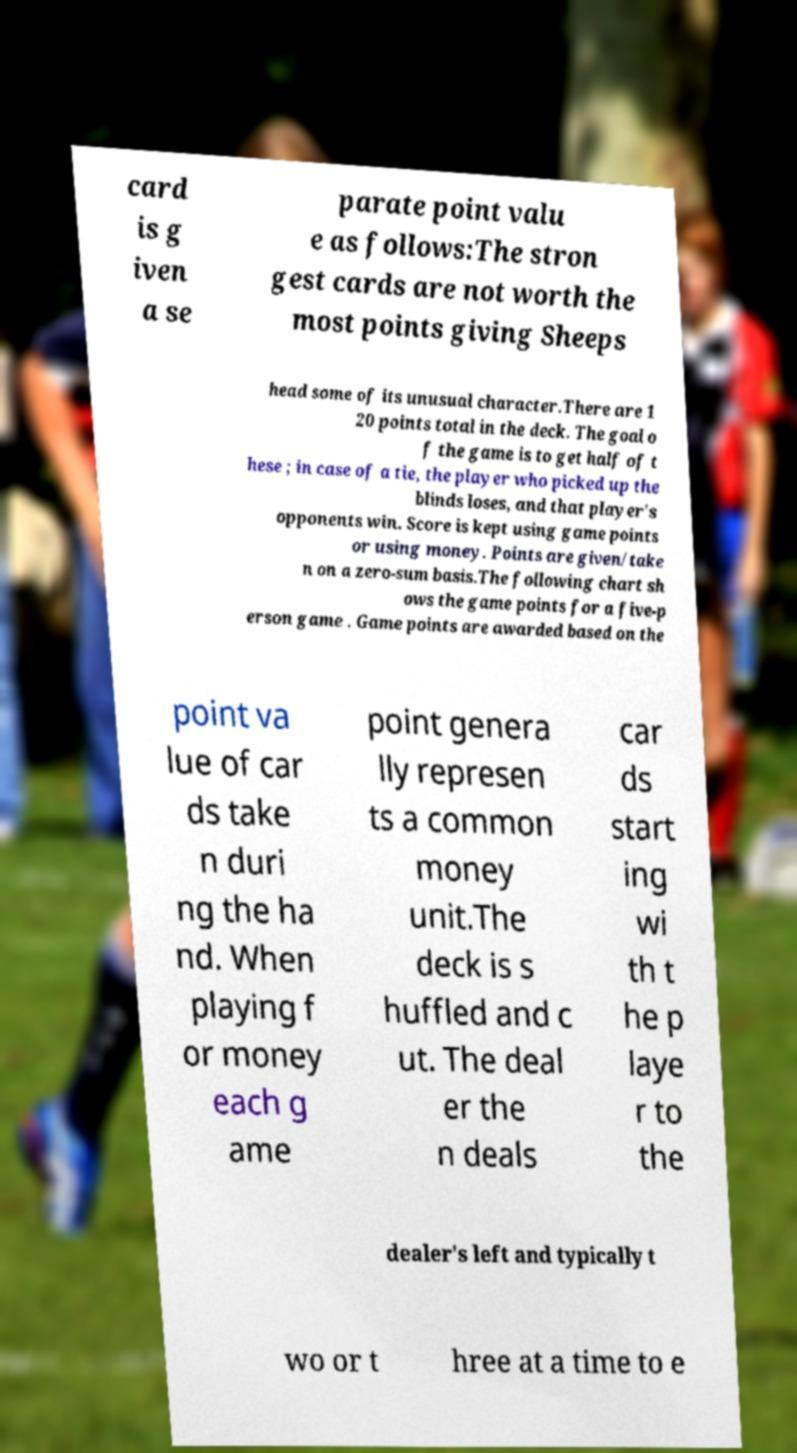Please identify and transcribe the text found in this image. card is g iven a se parate point valu e as follows:The stron gest cards are not worth the most points giving Sheeps head some of its unusual character.There are 1 20 points total in the deck. The goal o f the game is to get half of t hese ; in case of a tie, the player who picked up the blinds loses, and that player's opponents win. Score is kept using game points or using money. Points are given/take n on a zero-sum basis.The following chart sh ows the game points for a five-p erson game . Game points are awarded based on the point va lue of car ds take n duri ng the ha nd. When playing f or money each g ame point genera lly represen ts a common money unit.The deck is s huffled and c ut. The deal er the n deals car ds start ing wi th t he p laye r to the dealer's left and typically t wo or t hree at a time to e 